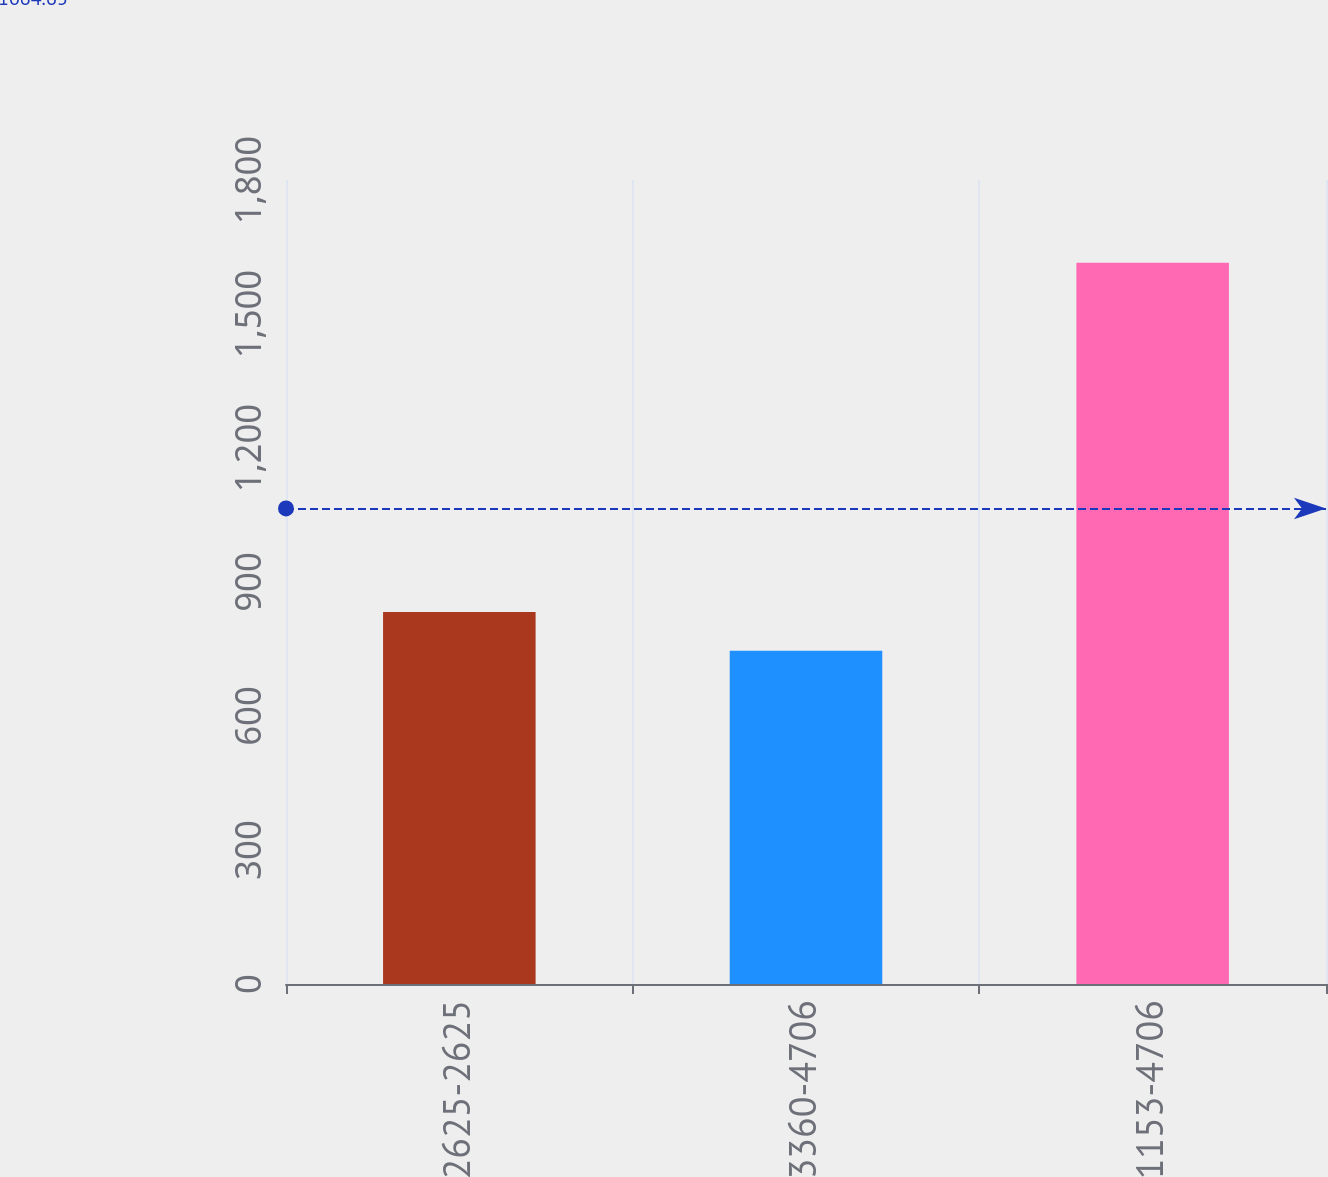Convert chart to OTSL. <chart><loc_0><loc_0><loc_500><loc_500><bar_chart><fcel>2625-2625<fcel>3360-4706<fcel>1153-4706<nl><fcel>832.9<fcel>746<fcel>1615<nl></chart> 